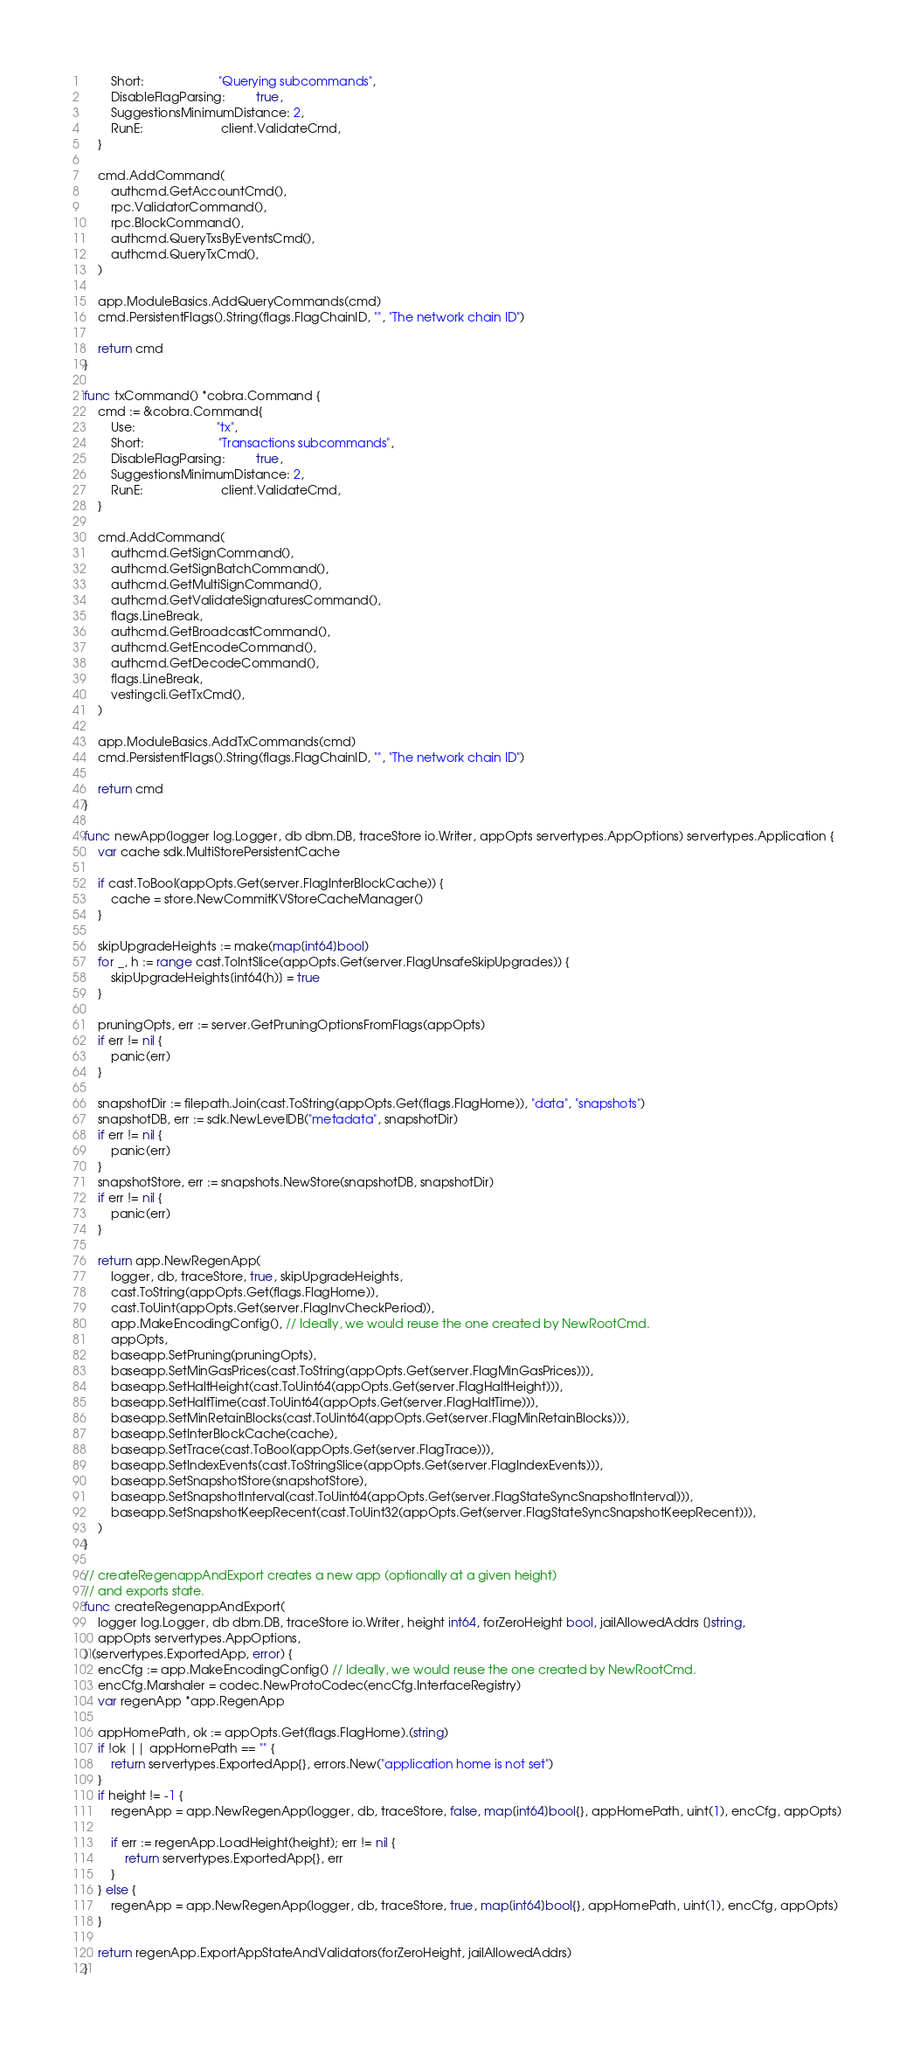Convert code to text. <code><loc_0><loc_0><loc_500><loc_500><_Go_>		Short:                      "Querying subcommands",
		DisableFlagParsing:         true,
		SuggestionsMinimumDistance: 2,
		RunE:                       client.ValidateCmd,
	}

	cmd.AddCommand(
		authcmd.GetAccountCmd(),
		rpc.ValidatorCommand(),
		rpc.BlockCommand(),
		authcmd.QueryTxsByEventsCmd(),
		authcmd.QueryTxCmd(),
	)

	app.ModuleBasics.AddQueryCommands(cmd)
	cmd.PersistentFlags().String(flags.FlagChainID, "", "The network chain ID")

	return cmd
}

func txCommand() *cobra.Command {
	cmd := &cobra.Command{
		Use:                        "tx",
		Short:                      "Transactions subcommands",
		DisableFlagParsing:         true,
		SuggestionsMinimumDistance: 2,
		RunE:                       client.ValidateCmd,
	}

	cmd.AddCommand(
		authcmd.GetSignCommand(),
		authcmd.GetSignBatchCommand(),
		authcmd.GetMultiSignCommand(),
		authcmd.GetValidateSignaturesCommand(),
		flags.LineBreak,
		authcmd.GetBroadcastCommand(),
		authcmd.GetEncodeCommand(),
		authcmd.GetDecodeCommand(),
		flags.LineBreak,
		vestingcli.GetTxCmd(),
	)

	app.ModuleBasics.AddTxCommands(cmd)
	cmd.PersistentFlags().String(flags.FlagChainID, "", "The network chain ID")

	return cmd
}

func newApp(logger log.Logger, db dbm.DB, traceStore io.Writer, appOpts servertypes.AppOptions) servertypes.Application {
	var cache sdk.MultiStorePersistentCache

	if cast.ToBool(appOpts.Get(server.FlagInterBlockCache)) {
		cache = store.NewCommitKVStoreCacheManager()
	}

	skipUpgradeHeights := make(map[int64]bool)
	for _, h := range cast.ToIntSlice(appOpts.Get(server.FlagUnsafeSkipUpgrades)) {
		skipUpgradeHeights[int64(h)] = true
	}

	pruningOpts, err := server.GetPruningOptionsFromFlags(appOpts)
	if err != nil {
		panic(err)
	}

	snapshotDir := filepath.Join(cast.ToString(appOpts.Get(flags.FlagHome)), "data", "snapshots")
	snapshotDB, err := sdk.NewLevelDB("metadata", snapshotDir)
	if err != nil {
		panic(err)
	}
	snapshotStore, err := snapshots.NewStore(snapshotDB, snapshotDir)
	if err != nil {
		panic(err)
	}

	return app.NewRegenApp(
		logger, db, traceStore, true, skipUpgradeHeights,
		cast.ToString(appOpts.Get(flags.FlagHome)),
		cast.ToUint(appOpts.Get(server.FlagInvCheckPeriod)),
		app.MakeEncodingConfig(), // Ideally, we would reuse the one created by NewRootCmd.
		appOpts,
		baseapp.SetPruning(pruningOpts),
		baseapp.SetMinGasPrices(cast.ToString(appOpts.Get(server.FlagMinGasPrices))),
		baseapp.SetHaltHeight(cast.ToUint64(appOpts.Get(server.FlagHaltHeight))),
		baseapp.SetHaltTime(cast.ToUint64(appOpts.Get(server.FlagHaltTime))),
		baseapp.SetMinRetainBlocks(cast.ToUint64(appOpts.Get(server.FlagMinRetainBlocks))),
		baseapp.SetInterBlockCache(cache),
		baseapp.SetTrace(cast.ToBool(appOpts.Get(server.FlagTrace))),
		baseapp.SetIndexEvents(cast.ToStringSlice(appOpts.Get(server.FlagIndexEvents))),
		baseapp.SetSnapshotStore(snapshotStore),
		baseapp.SetSnapshotInterval(cast.ToUint64(appOpts.Get(server.FlagStateSyncSnapshotInterval))),
		baseapp.SetSnapshotKeepRecent(cast.ToUint32(appOpts.Get(server.FlagStateSyncSnapshotKeepRecent))),
	)
}

// createRegenappAndExport creates a new app (optionally at a given height)
// and exports state.
func createRegenappAndExport(
	logger log.Logger, db dbm.DB, traceStore io.Writer, height int64, forZeroHeight bool, jailAllowedAddrs []string,
	appOpts servertypes.AppOptions,
) (servertypes.ExportedApp, error) {
	encCfg := app.MakeEncodingConfig() // Ideally, we would reuse the one created by NewRootCmd.
	encCfg.Marshaler = codec.NewProtoCodec(encCfg.InterfaceRegistry)
	var regenApp *app.RegenApp

	appHomePath, ok := appOpts.Get(flags.FlagHome).(string)
	if !ok || appHomePath == "" {
		return servertypes.ExportedApp{}, errors.New("application home is not set")
	}
	if height != -1 {
		regenApp = app.NewRegenApp(logger, db, traceStore, false, map[int64]bool{}, appHomePath, uint(1), encCfg, appOpts)

		if err := regenApp.LoadHeight(height); err != nil {
			return servertypes.ExportedApp{}, err
		}
	} else {
		regenApp = app.NewRegenApp(logger, db, traceStore, true, map[int64]bool{}, appHomePath, uint(1), encCfg, appOpts)
	}

	return regenApp.ExportAppStateAndValidators(forZeroHeight, jailAllowedAddrs)
}
</code> 